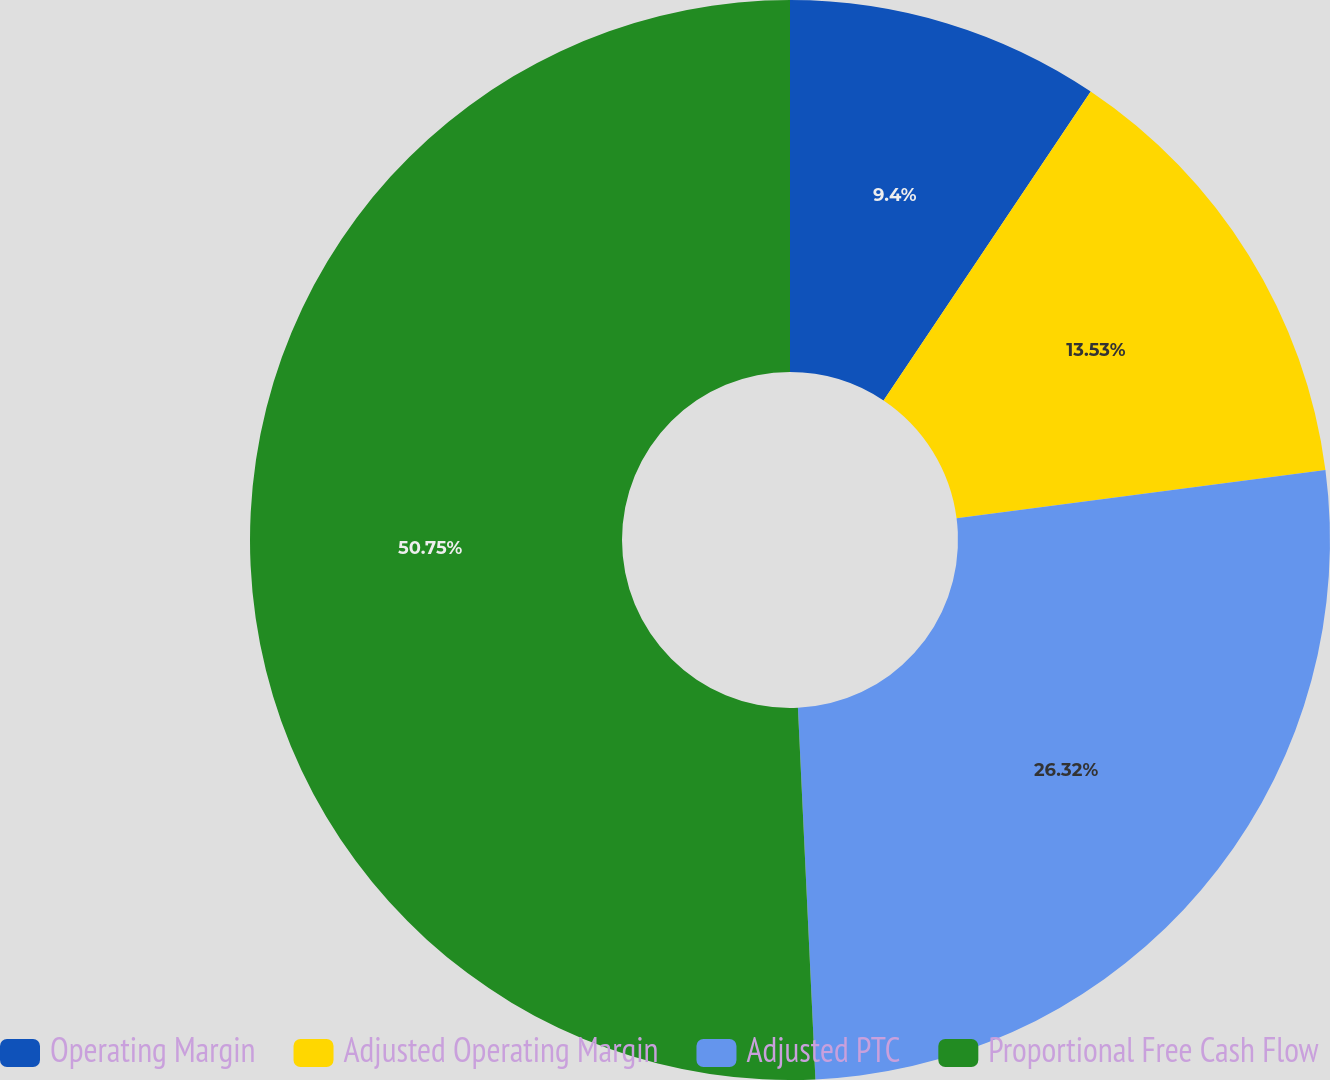Convert chart. <chart><loc_0><loc_0><loc_500><loc_500><pie_chart><fcel>Operating Margin<fcel>Adjusted Operating Margin<fcel>Adjusted PTC<fcel>Proportional Free Cash Flow<nl><fcel>9.4%<fcel>13.53%<fcel>26.32%<fcel>50.75%<nl></chart> 